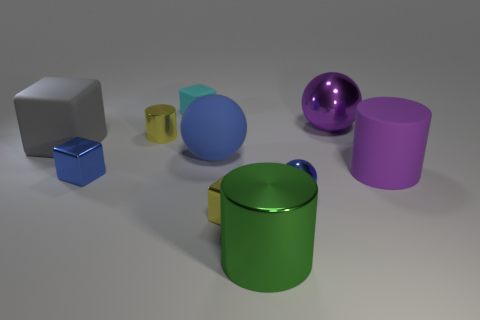Are there an equal number of large purple objects that are on the left side of the green metal thing and big gray matte things that are behind the large gray rubber block?
Provide a short and direct response. Yes. What is the size of the cylinder that is on the right side of the tiny blue object that is on the right side of the big green object?
Offer a very short reply. Large. Is there a blue metal ball of the same size as the purple matte cylinder?
Your response must be concise. No. The other sphere that is made of the same material as the small blue sphere is what color?
Provide a succinct answer. Purple. Are there fewer small cyan things than blue metallic cylinders?
Ensure brevity in your answer.  No. The cylinder that is both on the left side of the purple matte object and behind the large green cylinder is made of what material?
Offer a terse response. Metal. There is a tiny thing that is on the right side of the large green metal cylinder; is there a big purple rubber thing that is to the left of it?
Your answer should be very brief. No. What number of large metallic objects are the same color as the large matte cylinder?
Provide a short and direct response. 1. What is the material of the other sphere that is the same color as the large rubber sphere?
Provide a short and direct response. Metal. Are the yellow cylinder and the gray object made of the same material?
Your response must be concise. No. 